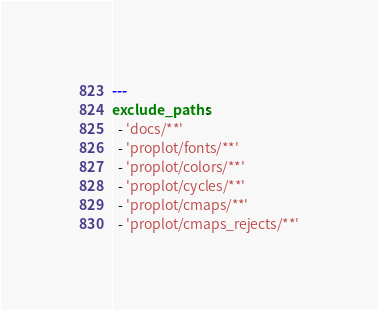<code> <loc_0><loc_0><loc_500><loc_500><_YAML_>---
exclude_paths:
  - 'docs/**'
  - 'proplot/fonts/**'
  - 'proplot/colors/**'
  - 'proplot/cycles/**'
  - 'proplot/cmaps/**'
  - 'proplot/cmaps_rejects/**'
</code> 